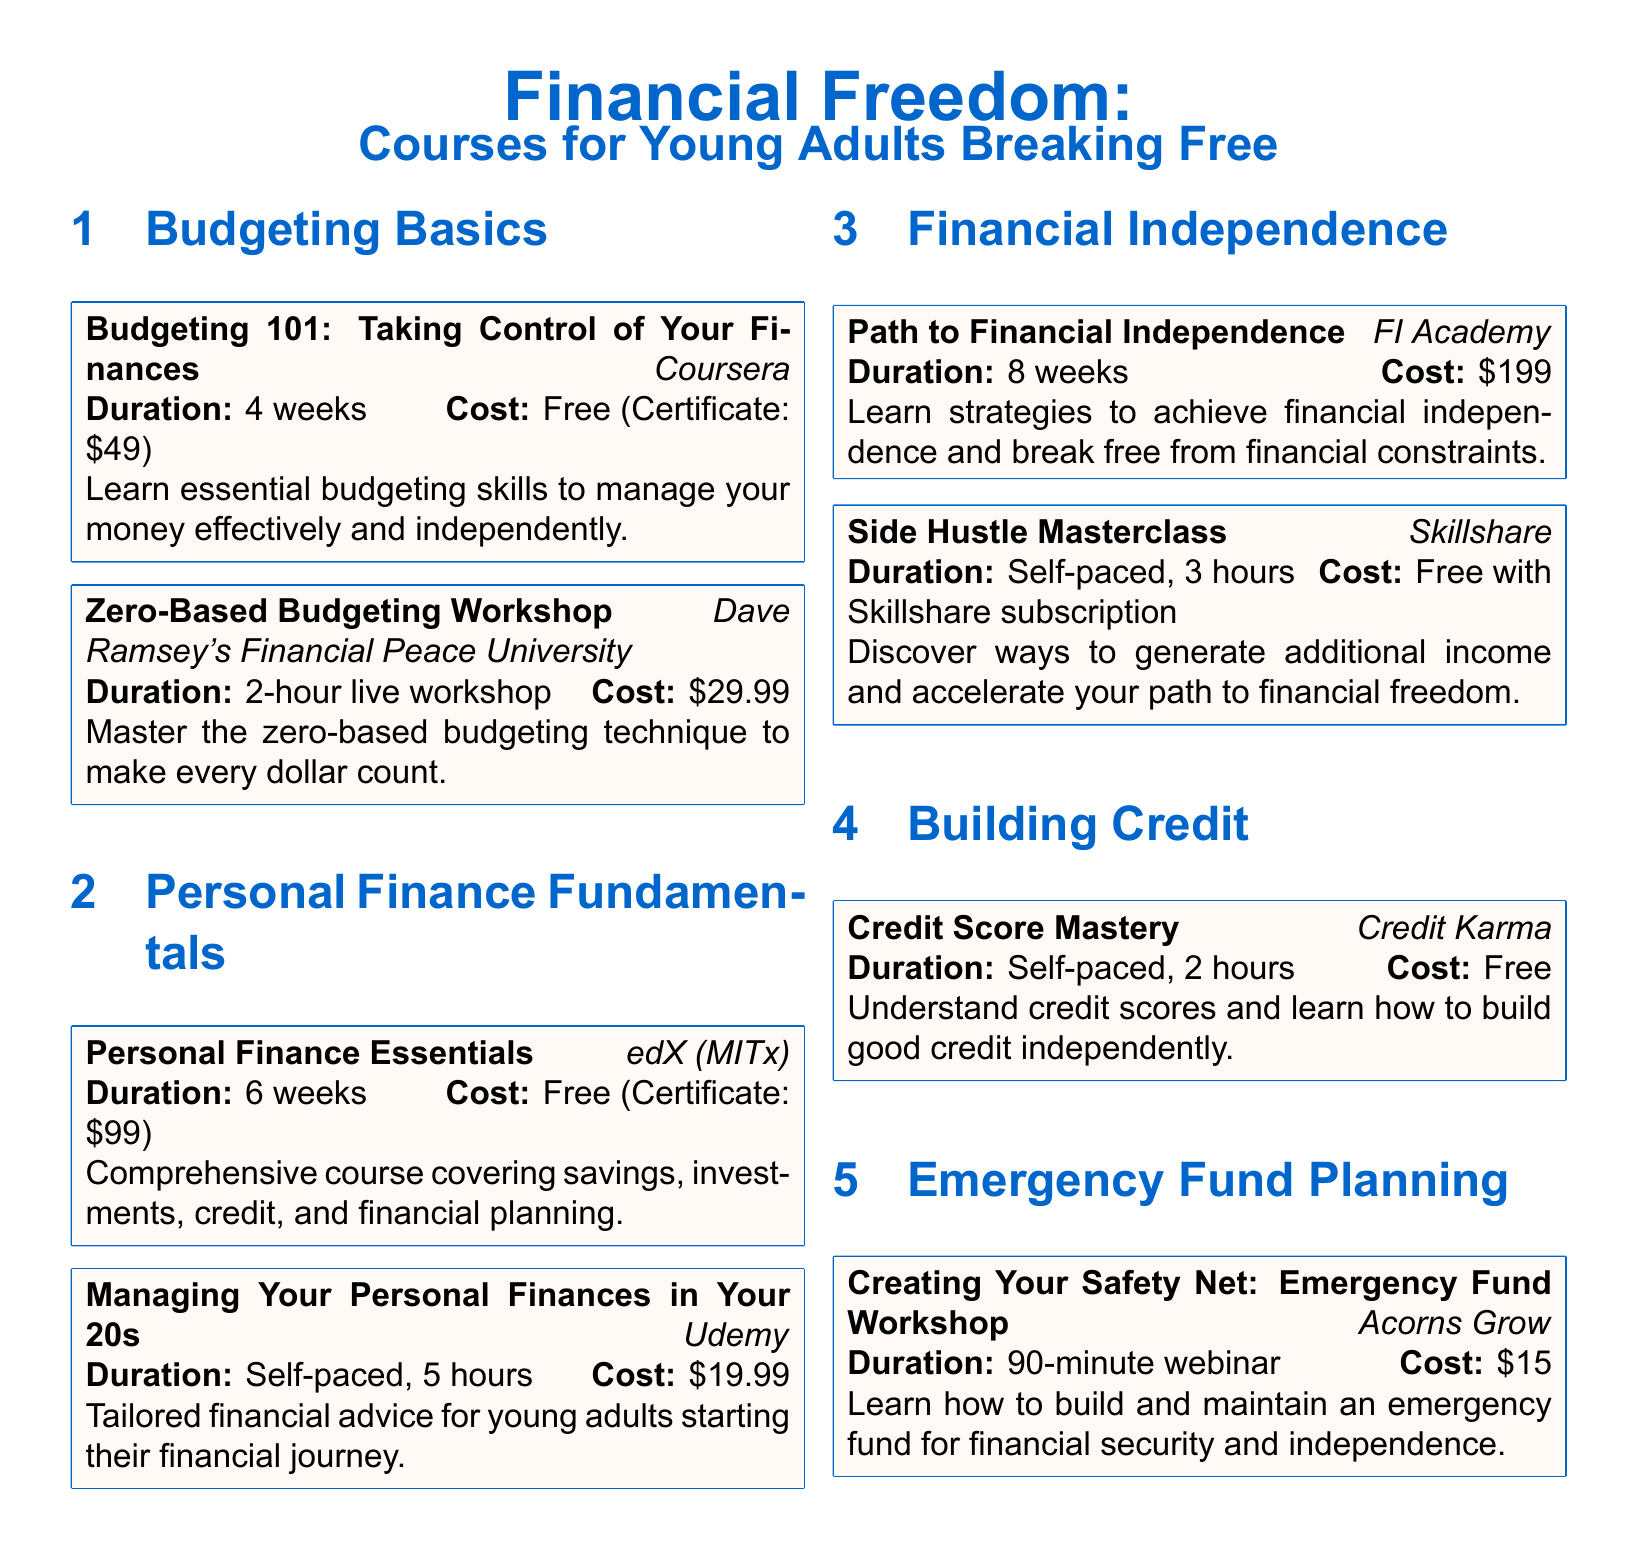What is the title of the first course in the Budgeting section? The title is listed at the top of the course box and is "Budgeting 101: Taking Control of Your Finances."
Answer: Budgeting 101: Taking Control of Your Finances How long does the "Personal Finance Essentials" course last? The duration is specified in the course box as "6 weeks."
Answer: 6 weeks What is the cost of the "Side Hustle Masterclass"? The cost is indicated in the course box as "Free with Skillshare subscription."
Answer: Free with Skillshare subscription How many weeks does the "Path to Financial Independence" course take? The course duration is noted in the course box as "8 weeks."
Answer: 8 weeks What type of workshop is "Creating Your Safety Net"? The type of workshop is shown in the course box and is a "90-minute webinar."
Answer: 90-minute webinar Which service offers the "Credit Score Mastery" course? The service providing this course is stated in the course box as "Credit Karma."
Answer: Credit Karma Which course focuses on preparing a budget where every dollar has a purpose? The course with this focus is highlighted in the title as "Zero-Based Budgeting Workshop."
Answer: Zero-Based Budgeting Workshop What is the cost of the course "Managing Your Personal Finances in Your 20s"? The cost is listed in the course box as "$19.99."
Answer: $19.99 Which organization hosts the "Budgeting 101" course? The organization hosting this course is mentioned in the course box as "Coursera."
Answer: Coursera 